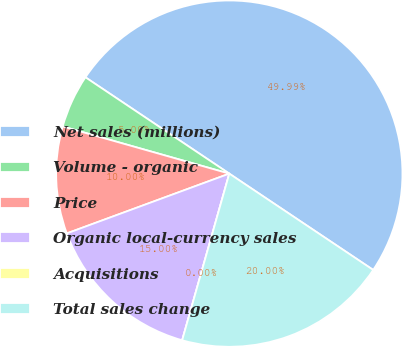<chart> <loc_0><loc_0><loc_500><loc_500><pie_chart><fcel>Net sales (millions)<fcel>Volume - organic<fcel>Price<fcel>Organic local-currency sales<fcel>Acquisitions<fcel>Total sales change<nl><fcel>49.99%<fcel>5.0%<fcel>10.0%<fcel>15.0%<fcel>0.0%<fcel>20.0%<nl></chart> 